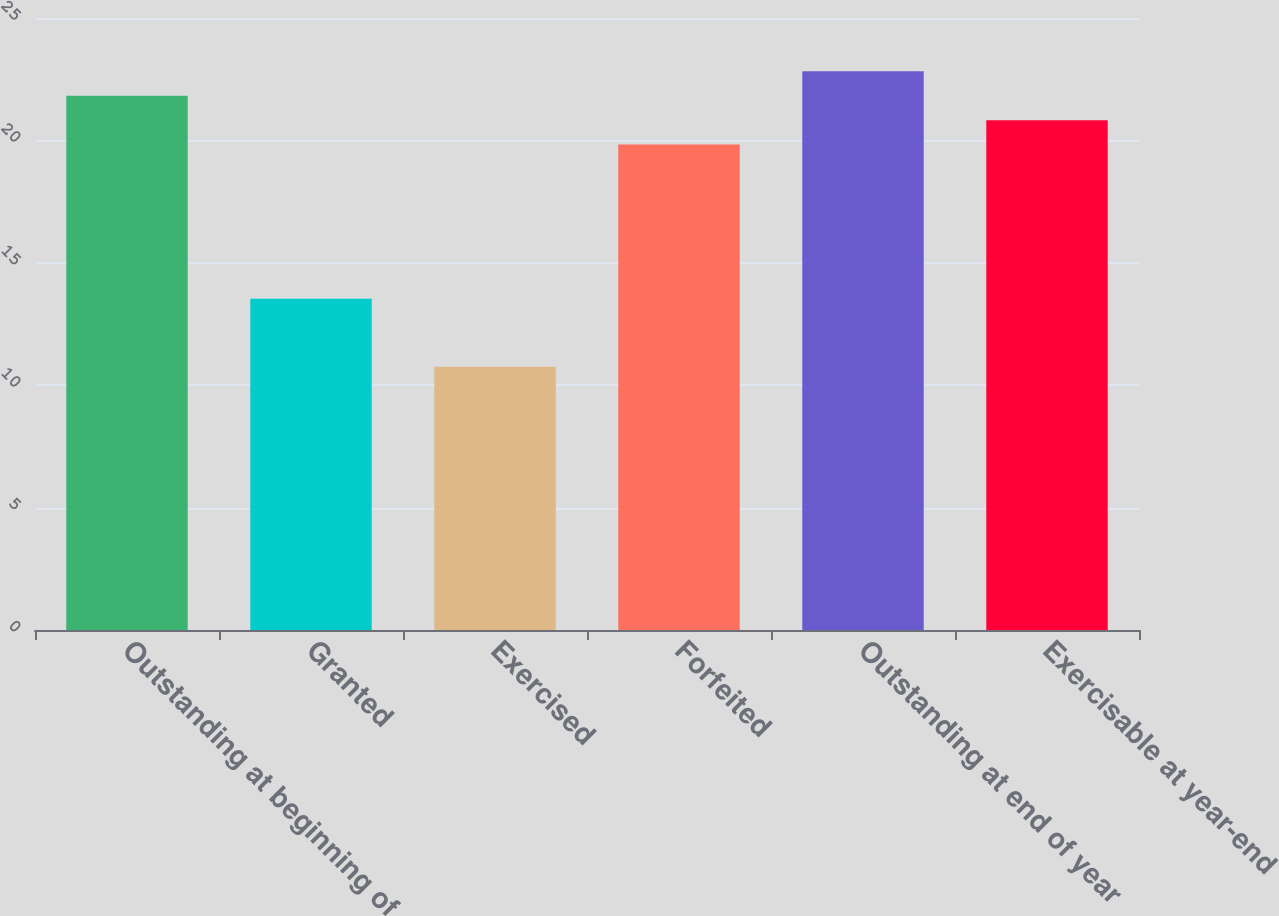<chart> <loc_0><loc_0><loc_500><loc_500><bar_chart><fcel>Outstanding at beginning of<fcel>Granted<fcel>Exercised<fcel>Forfeited<fcel>Outstanding at end of year<fcel>Exercisable at year-end<nl><fcel>21.82<fcel>13.53<fcel>10.75<fcel>19.83<fcel>22.82<fcel>20.82<nl></chart> 